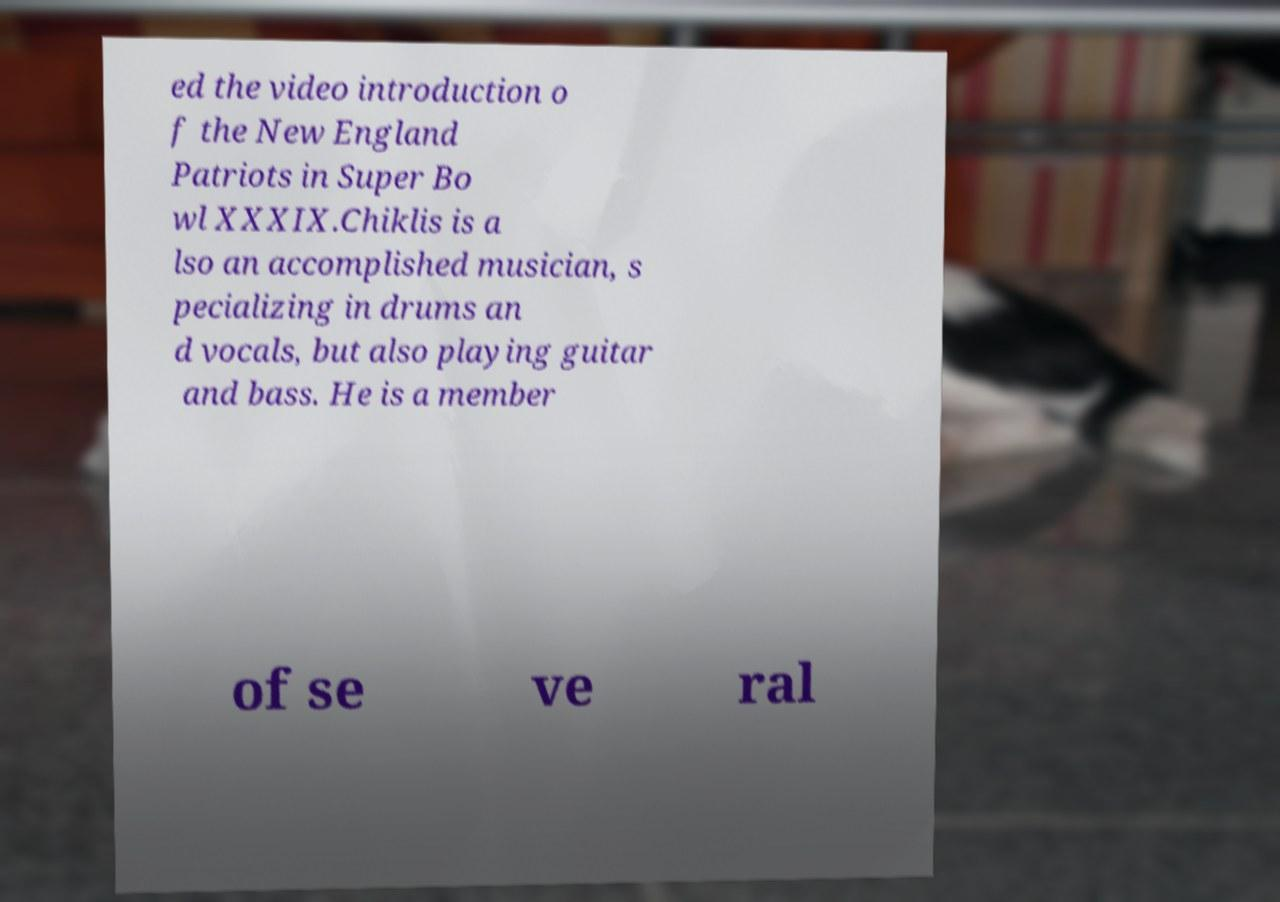For documentation purposes, I need the text within this image transcribed. Could you provide that? ed the video introduction o f the New England Patriots in Super Bo wl XXXIX.Chiklis is a lso an accomplished musician, s pecializing in drums an d vocals, but also playing guitar and bass. He is a member of se ve ral 